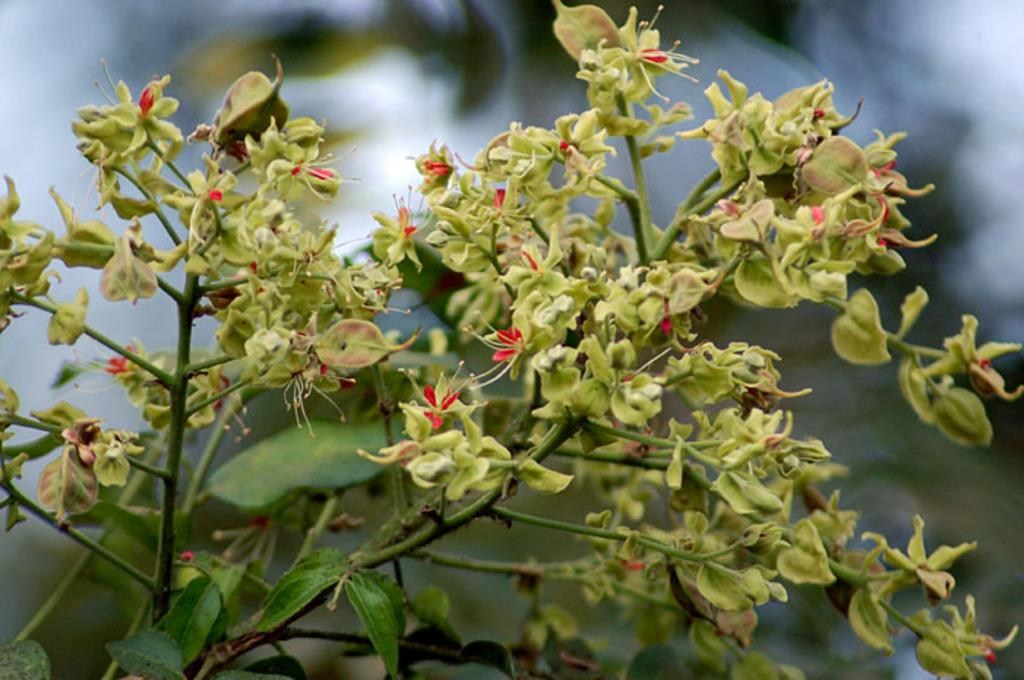What type of plants are visible in the image? There are plants with flowers in the image. Can you describe the background of the image? The background of the image is blurred. What direction is the pen pointing in the image? There is no pen present in the image. What type of market can be seen in the background of the image? The background of the image is blurred, and there is no market visible in the image. 